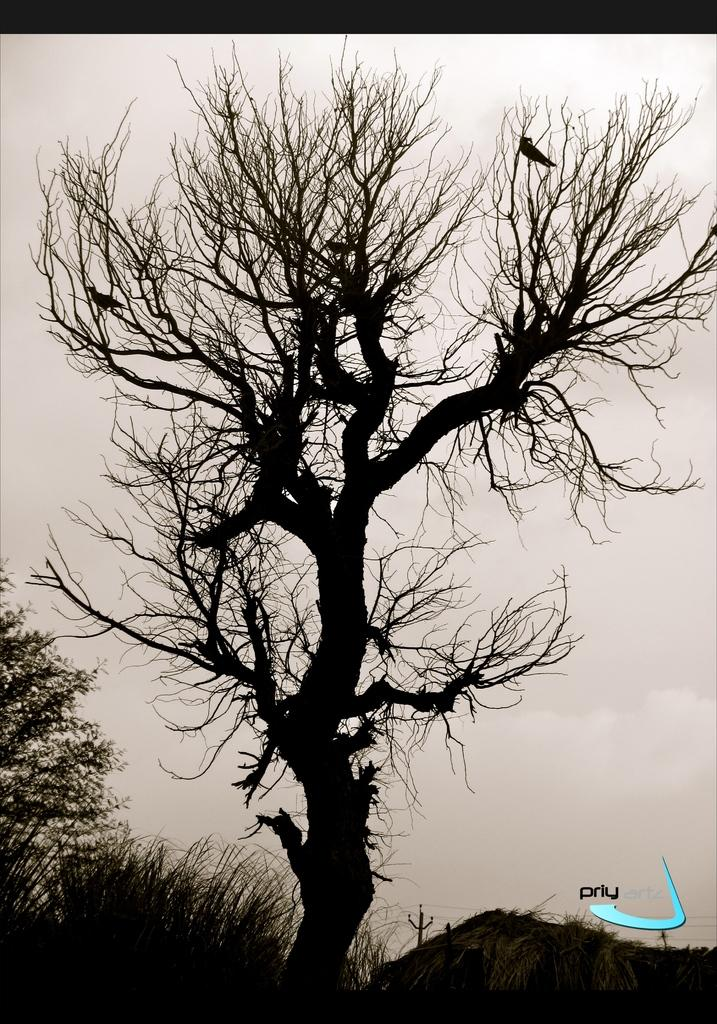What type of vegetation is at the bottom of the image? There are plants at the bottom of the image. What can be seen in the middle of the image? There is a tree in the middle of the image. What is visible in the background of the image? Clouds are visible in the background of the image. What type of tool is being used to create the fog in the image? There is no fog or tool present in the image. What is the need for the wrench in the image? There is no wrench present in the image, so it is not possible to determine its purpose. 